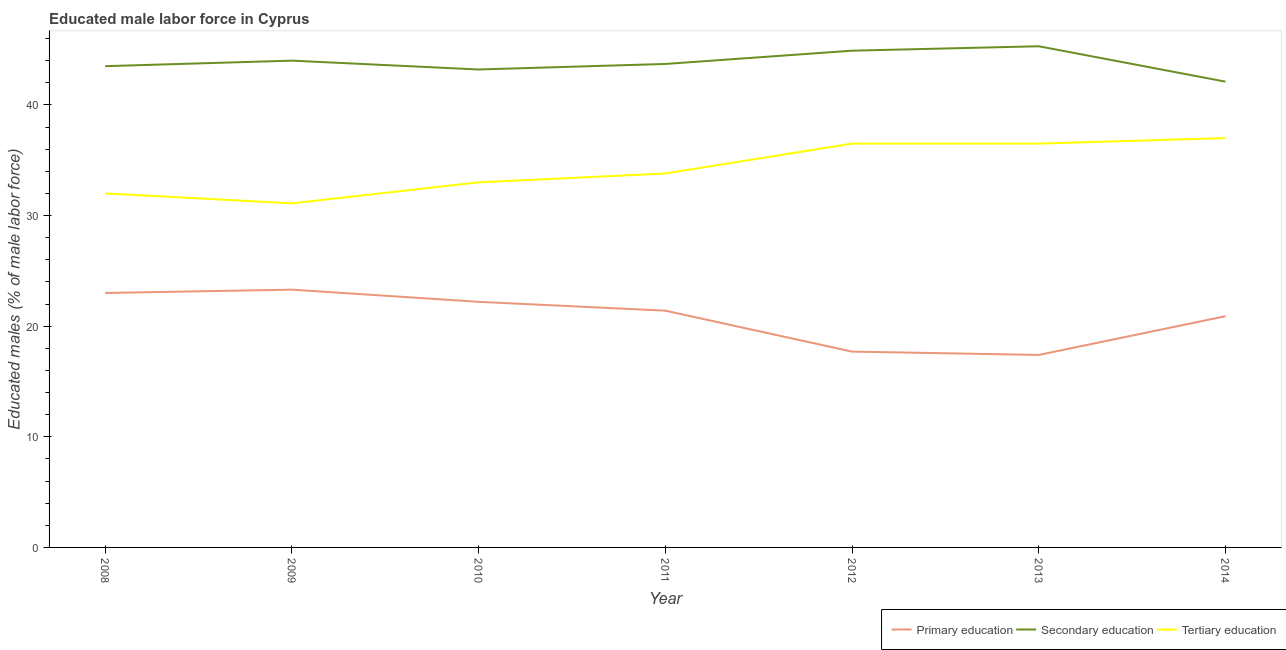How many different coloured lines are there?
Ensure brevity in your answer.  3. Is the number of lines equal to the number of legend labels?
Your response must be concise. Yes. What is the percentage of male labor force who received primary education in 2009?
Your answer should be very brief. 23.3. Across all years, what is the minimum percentage of male labor force who received secondary education?
Your response must be concise. 42.1. In which year was the percentage of male labor force who received secondary education minimum?
Your answer should be compact. 2014. What is the total percentage of male labor force who received tertiary education in the graph?
Keep it short and to the point. 239.9. What is the difference between the percentage of male labor force who received secondary education in 2010 and that in 2011?
Keep it short and to the point. -0.5. What is the difference between the percentage of male labor force who received secondary education in 2010 and the percentage of male labor force who received tertiary education in 2009?
Give a very brief answer. 12.1. What is the average percentage of male labor force who received tertiary education per year?
Provide a succinct answer. 34.27. In how many years, is the percentage of male labor force who received tertiary education greater than 40 %?
Offer a very short reply. 0. What is the ratio of the percentage of male labor force who received primary education in 2011 to that in 2013?
Ensure brevity in your answer.  1.23. Is the difference between the percentage of male labor force who received secondary education in 2012 and 2014 greater than the difference between the percentage of male labor force who received tertiary education in 2012 and 2014?
Your answer should be very brief. Yes. What is the difference between the highest and the lowest percentage of male labor force who received tertiary education?
Keep it short and to the point. 5.9. Is the sum of the percentage of male labor force who received tertiary education in 2008 and 2011 greater than the maximum percentage of male labor force who received primary education across all years?
Your answer should be very brief. Yes. Is it the case that in every year, the sum of the percentage of male labor force who received primary education and percentage of male labor force who received secondary education is greater than the percentage of male labor force who received tertiary education?
Your answer should be compact. Yes. How many lines are there?
Your response must be concise. 3. Does the graph contain grids?
Make the answer very short. No. What is the title of the graph?
Provide a succinct answer. Educated male labor force in Cyprus. Does "Coal" appear as one of the legend labels in the graph?
Your answer should be very brief. No. What is the label or title of the X-axis?
Your answer should be very brief. Year. What is the label or title of the Y-axis?
Keep it short and to the point. Educated males (% of male labor force). What is the Educated males (% of male labor force) of Primary education in 2008?
Your answer should be very brief. 23. What is the Educated males (% of male labor force) in Secondary education in 2008?
Ensure brevity in your answer.  43.5. What is the Educated males (% of male labor force) of Tertiary education in 2008?
Offer a terse response. 32. What is the Educated males (% of male labor force) of Primary education in 2009?
Give a very brief answer. 23.3. What is the Educated males (% of male labor force) of Tertiary education in 2009?
Your answer should be compact. 31.1. What is the Educated males (% of male labor force) of Primary education in 2010?
Give a very brief answer. 22.2. What is the Educated males (% of male labor force) in Secondary education in 2010?
Provide a succinct answer. 43.2. What is the Educated males (% of male labor force) of Primary education in 2011?
Ensure brevity in your answer.  21.4. What is the Educated males (% of male labor force) in Secondary education in 2011?
Your response must be concise. 43.7. What is the Educated males (% of male labor force) of Tertiary education in 2011?
Give a very brief answer. 33.8. What is the Educated males (% of male labor force) of Primary education in 2012?
Keep it short and to the point. 17.7. What is the Educated males (% of male labor force) of Secondary education in 2012?
Keep it short and to the point. 44.9. What is the Educated males (% of male labor force) of Tertiary education in 2012?
Make the answer very short. 36.5. What is the Educated males (% of male labor force) in Primary education in 2013?
Ensure brevity in your answer.  17.4. What is the Educated males (% of male labor force) in Secondary education in 2013?
Make the answer very short. 45.3. What is the Educated males (% of male labor force) in Tertiary education in 2013?
Provide a succinct answer. 36.5. What is the Educated males (% of male labor force) in Primary education in 2014?
Your answer should be compact. 20.9. What is the Educated males (% of male labor force) of Secondary education in 2014?
Keep it short and to the point. 42.1. Across all years, what is the maximum Educated males (% of male labor force) of Primary education?
Ensure brevity in your answer.  23.3. Across all years, what is the maximum Educated males (% of male labor force) of Secondary education?
Give a very brief answer. 45.3. Across all years, what is the minimum Educated males (% of male labor force) of Primary education?
Provide a short and direct response. 17.4. Across all years, what is the minimum Educated males (% of male labor force) in Secondary education?
Your answer should be compact. 42.1. Across all years, what is the minimum Educated males (% of male labor force) in Tertiary education?
Your response must be concise. 31.1. What is the total Educated males (% of male labor force) of Primary education in the graph?
Your answer should be very brief. 145.9. What is the total Educated males (% of male labor force) in Secondary education in the graph?
Give a very brief answer. 306.7. What is the total Educated males (% of male labor force) of Tertiary education in the graph?
Your answer should be very brief. 239.9. What is the difference between the Educated males (% of male labor force) in Secondary education in 2008 and that in 2009?
Your answer should be very brief. -0.5. What is the difference between the Educated males (% of male labor force) in Tertiary education in 2008 and that in 2009?
Give a very brief answer. 0.9. What is the difference between the Educated males (% of male labor force) of Primary education in 2008 and that in 2010?
Provide a short and direct response. 0.8. What is the difference between the Educated males (% of male labor force) in Secondary education in 2008 and that in 2010?
Offer a terse response. 0.3. What is the difference between the Educated males (% of male labor force) in Tertiary education in 2008 and that in 2010?
Provide a succinct answer. -1. What is the difference between the Educated males (% of male labor force) of Primary education in 2008 and that in 2011?
Ensure brevity in your answer.  1.6. What is the difference between the Educated males (% of male labor force) of Secondary education in 2008 and that in 2011?
Offer a very short reply. -0.2. What is the difference between the Educated males (% of male labor force) in Tertiary education in 2008 and that in 2013?
Make the answer very short. -4.5. What is the difference between the Educated males (% of male labor force) in Secondary education in 2009 and that in 2011?
Give a very brief answer. 0.3. What is the difference between the Educated males (% of male labor force) in Tertiary education in 2009 and that in 2011?
Offer a terse response. -2.7. What is the difference between the Educated males (% of male labor force) of Primary education in 2009 and that in 2013?
Make the answer very short. 5.9. What is the difference between the Educated males (% of male labor force) of Secondary education in 2009 and that in 2013?
Your answer should be compact. -1.3. What is the difference between the Educated males (% of male labor force) in Tertiary education in 2010 and that in 2012?
Offer a very short reply. -3.5. What is the difference between the Educated males (% of male labor force) in Primary education in 2010 and that in 2013?
Your response must be concise. 4.8. What is the difference between the Educated males (% of male labor force) of Secondary education in 2010 and that in 2013?
Give a very brief answer. -2.1. What is the difference between the Educated males (% of male labor force) in Tertiary education in 2010 and that in 2013?
Make the answer very short. -3.5. What is the difference between the Educated males (% of male labor force) in Tertiary education in 2011 and that in 2012?
Your answer should be compact. -2.7. What is the difference between the Educated males (% of male labor force) in Primary education in 2011 and that in 2013?
Your response must be concise. 4. What is the difference between the Educated males (% of male labor force) of Secondary education in 2011 and that in 2013?
Your answer should be compact. -1.6. What is the difference between the Educated males (% of male labor force) of Tertiary education in 2011 and that in 2013?
Provide a succinct answer. -2.7. What is the difference between the Educated males (% of male labor force) in Primary education in 2011 and that in 2014?
Your response must be concise. 0.5. What is the difference between the Educated males (% of male labor force) in Secondary education in 2011 and that in 2014?
Offer a terse response. 1.6. What is the difference between the Educated males (% of male labor force) of Tertiary education in 2011 and that in 2014?
Give a very brief answer. -3.2. What is the difference between the Educated males (% of male labor force) in Tertiary education in 2012 and that in 2013?
Provide a succinct answer. 0. What is the difference between the Educated males (% of male labor force) in Primary education in 2008 and the Educated males (% of male labor force) in Secondary education in 2009?
Your response must be concise. -21. What is the difference between the Educated males (% of male labor force) in Primary education in 2008 and the Educated males (% of male labor force) in Tertiary education in 2009?
Offer a very short reply. -8.1. What is the difference between the Educated males (% of male labor force) in Secondary education in 2008 and the Educated males (% of male labor force) in Tertiary education in 2009?
Keep it short and to the point. 12.4. What is the difference between the Educated males (% of male labor force) of Primary education in 2008 and the Educated males (% of male labor force) of Secondary education in 2010?
Offer a very short reply. -20.2. What is the difference between the Educated males (% of male labor force) in Primary education in 2008 and the Educated males (% of male labor force) in Secondary education in 2011?
Ensure brevity in your answer.  -20.7. What is the difference between the Educated males (% of male labor force) in Primary education in 2008 and the Educated males (% of male labor force) in Secondary education in 2012?
Give a very brief answer. -21.9. What is the difference between the Educated males (% of male labor force) of Primary education in 2008 and the Educated males (% of male labor force) of Secondary education in 2013?
Your response must be concise. -22.3. What is the difference between the Educated males (% of male labor force) in Primary education in 2008 and the Educated males (% of male labor force) in Tertiary education in 2013?
Provide a short and direct response. -13.5. What is the difference between the Educated males (% of male labor force) of Secondary education in 2008 and the Educated males (% of male labor force) of Tertiary education in 2013?
Give a very brief answer. 7. What is the difference between the Educated males (% of male labor force) of Primary education in 2008 and the Educated males (% of male labor force) of Secondary education in 2014?
Offer a terse response. -19.1. What is the difference between the Educated males (% of male labor force) of Primary education in 2008 and the Educated males (% of male labor force) of Tertiary education in 2014?
Give a very brief answer. -14. What is the difference between the Educated males (% of male labor force) of Secondary education in 2008 and the Educated males (% of male labor force) of Tertiary education in 2014?
Offer a terse response. 6.5. What is the difference between the Educated males (% of male labor force) of Primary education in 2009 and the Educated males (% of male labor force) of Secondary education in 2010?
Keep it short and to the point. -19.9. What is the difference between the Educated males (% of male labor force) in Primary education in 2009 and the Educated males (% of male labor force) in Secondary education in 2011?
Give a very brief answer. -20.4. What is the difference between the Educated males (% of male labor force) in Primary education in 2009 and the Educated males (% of male labor force) in Tertiary education in 2011?
Make the answer very short. -10.5. What is the difference between the Educated males (% of male labor force) of Primary education in 2009 and the Educated males (% of male labor force) of Secondary education in 2012?
Keep it short and to the point. -21.6. What is the difference between the Educated males (% of male labor force) of Secondary education in 2009 and the Educated males (% of male labor force) of Tertiary education in 2012?
Provide a short and direct response. 7.5. What is the difference between the Educated males (% of male labor force) of Primary education in 2009 and the Educated males (% of male labor force) of Tertiary education in 2013?
Ensure brevity in your answer.  -13.2. What is the difference between the Educated males (% of male labor force) in Primary education in 2009 and the Educated males (% of male labor force) in Secondary education in 2014?
Your answer should be compact. -18.8. What is the difference between the Educated males (% of male labor force) of Primary education in 2009 and the Educated males (% of male labor force) of Tertiary education in 2014?
Offer a terse response. -13.7. What is the difference between the Educated males (% of male labor force) in Primary education in 2010 and the Educated males (% of male labor force) in Secondary education in 2011?
Your response must be concise. -21.5. What is the difference between the Educated males (% of male labor force) in Secondary education in 2010 and the Educated males (% of male labor force) in Tertiary education in 2011?
Keep it short and to the point. 9.4. What is the difference between the Educated males (% of male labor force) in Primary education in 2010 and the Educated males (% of male labor force) in Secondary education in 2012?
Ensure brevity in your answer.  -22.7. What is the difference between the Educated males (% of male labor force) of Primary education in 2010 and the Educated males (% of male labor force) of Tertiary education in 2012?
Make the answer very short. -14.3. What is the difference between the Educated males (% of male labor force) of Primary education in 2010 and the Educated males (% of male labor force) of Secondary education in 2013?
Your answer should be compact. -23.1. What is the difference between the Educated males (% of male labor force) of Primary education in 2010 and the Educated males (% of male labor force) of Tertiary education in 2013?
Your answer should be very brief. -14.3. What is the difference between the Educated males (% of male labor force) in Primary education in 2010 and the Educated males (% of male labor force) in Secondary education in 2014?
Make the answer very short. -19.9. What is the difference between the Educated males (% of male labor force) in Primary education in 2010 and the Educated males (% of male labor force) in Tertiary education in 2014?
Make the answer very short. -14.8. What is the difference between the Educated males (% of male labor force) of Secondary education in 2010 and the Educated males (% of male labor force) of Tertiary education in 2014?
Your response must be concise. 6.2. What is the difference between the Educated males (% of male labor force) in Primary education in 2011 and the Educated males (% of male labor force) in Secondary education in 2012?
Offer a terse response. -23.5. What is the difference between the Educated males (% of male labor force) of Primary education in 2011 and the Educated males (% of male labor force) of Tertiary education in 2012?
Your answer should be compact. -15.1. What is the difference between the Educated males (% of male labor force) in Primary education in 2011 and the Educated males (% of male labor force) in Secondary education in 2013?
Keep it short and to the point. -23.9. What is the difference between the Educated males (% of male labor force) in Primary education in 2011 and the Educated males (% of male labor force) in Tertiary education in 2013?
Your response must be concise. -15.1. What is the difference between the Educated males (% of male labor force) of Secondary education in 2011 and the Educated males (% of male labor force) of Tertiary education in 2013?
Make the answer very short. 7.2. What is the difference between the Educated males (% of male labor force) in Primary education in 2011 and the Educated males (% of male labor force) in Secondary education in 2014?
Your response must be concise. -20.7. What is the difference between the Educated males (% of male labor force) of Primary education in 2011 and the Educated males (% of male labor force) of Tertiary education in 2014?
Provide a succinct answer. -15.6. What is the difference between the Educated males (% of male labor force) in Primary education in 2012 and the Educated males (% of male labor force) in Secondary education in 2013?
Make the answer very short. -27.6. What is the difference between the Educated males (% of male labor force) of Primary education in 2012 and the Educated males (% of male labor force) of Tertiary education in 2013?
Keep it short and to the point. -18.8. What is the difference between the Educated males (% of male labor force) of Secondary education in 2012 and the Educated males (% of male labor force) of Tertiary education in 2013?
Your answer should be very brief. 8.4. What is the difference between the Educated males (% of male labor force) in Primary education in 2012 and the Educated males (% of male labor force) in Secondary education in 2014?
Make the answer very short. -24.4. What is the difference between the Educated males (% of male labor force) in Primary education in 2012 and the Educated males (% of male labor force) in Tertiary education in 2014?
Your response must be concise. -19.3. What is the difference between the Educated males (% of male labor force) of Secondary education in 2012 and the Educated males (% of male labor force) of Tertiary education in 2014?
Your answer should be compact. 7.9. What is the difference between the Educated males (% of male labor force) in Primary education in 2013 and the Educated males (% of male labor force) in Secondary education in 2014?
Your answer should be compact. -24.7. What is the difference between the Educated males (% of male labor force) of Primary education in 2013 and the Educated males (% of male labor force) of Tertiary education in 2014?
Provide a short and direct response. -19.6. What is the difference between the Educated males (% of male labor force) of Secondary education in 2013 and the Educated males (% of male labor force) of Tertiary education in 2014?
Provide a succinct answer. 8.3. What is the average Educated males (% of male labor force) of Primary education per year?
Your response must be concise. 20.84. What is the average Educated males (% of male labor force) of Secondary education per year?
Your answer should be compact. 43.81. What is the average Educated males (% of male labor force) of Tertiary education per year?
Provide a succinct answer. 34.27. In the year 2008, what is the difference between the Educated males (% of male labor force) in Primary education and Educated males (% of male labor force) in Secondary education?
Make the answer very short. -20.5. In the year 2008, what is the difference between the Educated males (% of male labor force) of Primary education and Educated males (% of male labor force) of Tertiary education?
Make the answer very short. -9. In the year 2008, what is the difference between the Educated males (% of male labor force) of Secondary education and Educated males (% of male labor force) of Tertiary education?
Your response must be concise. 11.5. In the year 2009, what is the difference between the Educated males (% of male labor force) of Primary education and Educated males (% of male labor force) of Secondary education?
Your answer should be compact. -20.7. In the year 2009, what is the difference between the Educated males (% of male labor force) in Secondary education and Educated males (% of male labor force) in Tertiary education?
Provide a short and direct response. 12.9. In the year 2010, what is the difference between the Educated males (% of male labor force) in Primary education and Educated males (% of male labor force) in Secondary education?
Provide a succinct answer. -21. In the year 2010, what is the difference between the Educated males (% of male labor force) in Primary education and Educated males (% of male labor force) in Tertiary education?
Ensure brevity in your answer.  -10.8. In the year 2011, what is the difference between the Educated males (% of male labor force) of Primary education and Educated males (% of male labor force) of Secondary education?
Offer a terse response. -22.3. In the year 2012, what is the difference between the Educated males (% of male labor force) in Primary education and Educated males (% of male labor force) in Secondary education?
Give a very brief answer. -27.2. In the year 2012, what is the difference between the Educated males (% of male labor force) in Primary education and Educated males (% of male labor force) in Tertiary education?
Keep it short and to the point. -18.8. In the year 2013, what is the difference between the Educated males (% of male labor force) of Primary education and Educated males (% of male labor force) of Secondary education?
Ensure brevity in your answer.  -27.9. In the year 2013, what is the difference between the Educated males (% of male labor force) in Primary education and Educated males (% of male labor force) in Tertiary education?
Your answer should be very brief. -19.1. In the year 2013, what is the difference between the Educated males (% of male labor force) in Secondary education and Educated males (% of male labor force) in Tertiary education?
Provide a short and direct response. 8.8. In the year 2014, what is the difference between the Educated males (% of male labor force) in Primary education and Educated males (% of male labor force) in Secondary education?
Provide a succinct answer. -21.2. In the year 2014, what is the difference between the Educated males (% of male labor force) of Primary education and Educated males (% of male labor force) of Tertiary education?
Provide a succinct answer. -16.1. In the year 2014, what is the difference between the Educated males (% of male labor force) in Secondary education and Educated males (% of male labor force) in Tertiary education?
Offer a very short reply. 5.1. What is the ratio of the Educated males (% of male labor force) in Primary education in 2008 to that in 2009?
Your answer should be very brief. 0.99. What is the ratio of the Educated males (% of male labor force) in Secondary education in 2008 to that in 2009?
Ensure brevity in your answer.  0.99. What is the ratio of the Educated males (% of male labor force) in Tertiary education in 2008 to that in 2009?
Keep it short and to the point. 1.03. What is the ratio of the Educated males (% of male labor force) of Primary education in 2008 to that in 2010?
Offer a very short reply. 1.04. What is the ratio of the Educated males (% of male labor force) of Secondary education in 2008 to that in 2010?
Offer a very short reply. 1.01. What is the ratio of the Educated males (% of male labor force) in Tertiary education in 2008 to that in 2010?
Provide a succinct answer. 0.97. What is the ratio of the Educated males (% of male labor force) in Primary education in 2008 to that in 2011?
Keep it short and to the point. 1.07. What is the ratio of the Educated males (% of male labor force) in Tertiary education in 2008 to that in 2011?
Offer a terse response. 0.95. What is the ratio of the Educated males (% of male labor force) in Primary education in 2008 to that in 2012?
Give a very brief answer. 1.3. What is the ratio of the Educated males (% of male labor force) of Secondary education in 2008 to that in 2012?
Ensure brevity in your answer.  0.97. What is the ratio of the Educated males (% of male labor force) in Tertiary education in 2008 to that in 2012?
Make the answer very short. 0.88. What is the ratio of the Educated males (% of male labor force) in Primary education in 2008 to that in 2013?
Ensure brevity in your answer.  1.32. What is the ratio of the Educated males (% of male labor force) in Secondary education in 2008 to that in 2013?
Keep it short and to the point. 0.96. What is the ratio of the Educated males (% of male labor force) of Tertiary education in 2008 to that in 2013?
Provide a succinct answer. 0.88. What is the ratio of the Educated males (% of male labor force) of Primary education in 2008 to that in 2014?
Ensure brevity in your answer.  1.1. What is the ratio of the Educated males (% of male labor force) in Secondary education in 2008 to that in 2014?
Offer a very short reply. 1.03. What is the ratio of the Educated males (% of male labor force) of Tertiary education in 2008 to that in 2014?
Offer a terse response. 0.86. What is the ratio of the Educated males (% of male labor force) in Primary education in 2009 to that in 2010?
Provide a short and direct response. 1.05. What is the ratio of the Educated males (% of male labor force) in Secondary education in 2009 to that in 2010?
Ensure brevity in your answer.  1.02. What is the ratio of the Educated males (% of male labor force) in Tertiary education in 2009 to that in 2010?
Your answer should be very brief. 0.94. What is the ratio of the Educated males (% of male labor force) of Primary education in 2009 to that in 2011?
Keep it short and to the point. 1.09. What is the ratio of the Educated males (% of male labor force) of Secondary education in 2009 to that in 2011?
Keep it short and to the point. 1.01. What is the ratio of the Educated males (% of male labor force) in Tertiary education in 2009 to that in 2011?
Provide a short and direct response. 0.92. What is the ratio of the Educated males (% of male labor force) of Primary education in 2009 to that in 2012?
Keep it short and to the point. 1.32. What is the ratio of the Educated males (% of male labor force) in Secondary education in 2009 to that in 2012?
Ensure brevity in your answer.  0.98. What is the ratio of the Educated males (% of male labor force) of Tertiary education in 2009 to that in 2012?
Offer a very short reply. 0.85. What is the ratio of the Educated males (% of male labor force) of Primary education in 2009 to that in 2013?
Your answer should be very brief. 1.34. What is the ratio of the Educated males (% of male labor force) of Secondary education in 2009 to that in 2013?
Ensure brevity in your answer.  0.97. What is the ratio of the Educated males (% of male labor force) in Tertiary education in 2009 to that in 2013?
Ensure brevity in your answer.  0.85. What is the ratio of the Educated males (% of male labor force) of Primary education in 2009 to that in 2014?
Your response must be concise. 1.11. What is the ratio of the Educated males (% of male labor force) in Secondary education in 2009 to that in 2014?
Ensure brevity in your answer.  1.05. What is the ratio of the Educated males (% of male labor force) in Tertiary education in 2009 to that in 2014?
Give a very brief answer. 0.84. What is the ratio of the Educated males (% of male labor force) in Primary education in 2010 to that in 2011?
Offer a very short reply. 1.04. What is the ratio of the Educated males (% of male labor force) in Tertiary education in 2010 to that in 2011?
Make the answer very short. 0.98. What is the ratio of the Educated males (% of male labor force) of Primary education in 2010 to that in 2012?
Make the answer very short. 1.25. What is the ratio of the Educated males (% of male labor force) of Secondary education in 2010 to that in 2012?
Your answer should be compact. 0.96. What is the ratio of the Educated males (% of male labor force) of Tertiary education in 2010 to that in 2012?
Provide a short and direct response. 0.9. What is the ratio of the Educated males (% of male labor force) in Primary education in 2010 to that in 2013?
Your response must be concise. 1.28. What is the ratio of the Educated males (% of male labor force) of Secondary education in 2010 to that in 2013?
Your answer should be very brief. 0.95. What is the ratio of the Educated males (% of male labor force) of Tertiary education in 2010 to that in 2013?
Provide a short and direct response. 0.9. What is the ratio of the Educated males (% of male labor force) of Primary education in 2010 to that in 2014?
Give a very brief answer. 1.06. What is the ratio of the Educated males (% of male labor force) in Secondary education in 2010 to that in 2014?
Offer a terse response. 1.03. What is the ratio of the Educated males (% of male labor force) in Tertiary education in 2010 to that in 2014?
Offer a very short reply. 0.89. What is the ratio of the Educated males (% of male labor force) in Primary education in 2011 to that in 2012?
Ensure brevity in your answer.  1.21. What is the ratio of the Educated males (% of male labor force) of Secondary education in 2011 to that in 2012?
Make the answer very short. 0.97. What is the ratio of the Educated males (% of male labor force) in Tertiary education in 2011 to that in 2012?
Ensure brevity in your answer.  0.93. What is the ratio of the Educated males (% of male labor force) of Primary education in 2011 to that in 2013?
Make the answer very short. 1.23. What is the ratio of the Educated males (% of male labor force) of Secondary education in 2011 to that in 2013?
Provide a succinct answer. 0.96. What is the ratio of the Educated males (% of male labor force) of Tertiary education in 2011 to that in 2013?
Offer a terse response. 0.93. What is the ratio of the Educated males (% of male labor force) of Primary education in 2011 to that in 2014?
Provide a succinct answer. 1.02. What is the ratio of the Educated males (% of male labor force) in Secondary education in 2011 to that in 2014?
Keep it short and to the point. 1.04. What is the ratio of the Educated males (% of male labor force) in Tertiary education in 2011 to that in 2014?
Provide a succinct answer. 0.91. What is the ratio of the Educated males (% of male labor force) in Primary education in 2012 to that in 2013?
Offer a terse response. 1.02. What is the ratio of the Educated males (% of male labor force) of Secondary education in 2012 to that in 2013?
Provide a succinct answer. 0.99. What is the ratio of the Educated males (% of male labor force) in Tertiary education in 2012 to that in 2013?
Make the answer very short. 1. What is the ratio of the Educated males (% of male labor force) of Primary education in 2012 to that in 2014?
Offer a very short reply. 0.85. What is the ratio of the Educated males (% of male labor force) of Secondary education in 2012 to that in 2014?
Provide a short and direct response. 1.07. What is the ratio of the Educated males (% of male labor force) in Tertiary education in 2012 to that in 2014?
Keep it short and to the point. 0.99. What is the ratio of the Educated males (% of male labor force) in Primary education in 2013 to that in 2014?
Offer a terse response. 0.83. What is the ratio of the Educated males (% of male labor force) in Secondary education in 2013 to that in 2014?
Offer a terse response. 1.08. What is the ratio of the Educated males (% of male labor force) in Tertiary education in 2013 to that in 2014?
Your answer should be compact. 0.99. What is the difference between the highest and the second highest Educated males (% of male labor force) in Primary education?
Your answer should be very brief. 0.3. What is the difference between the highest and the lowest Educated males (% of male labor force) of Primary education?
Keep it short and to the point. 5.9. 